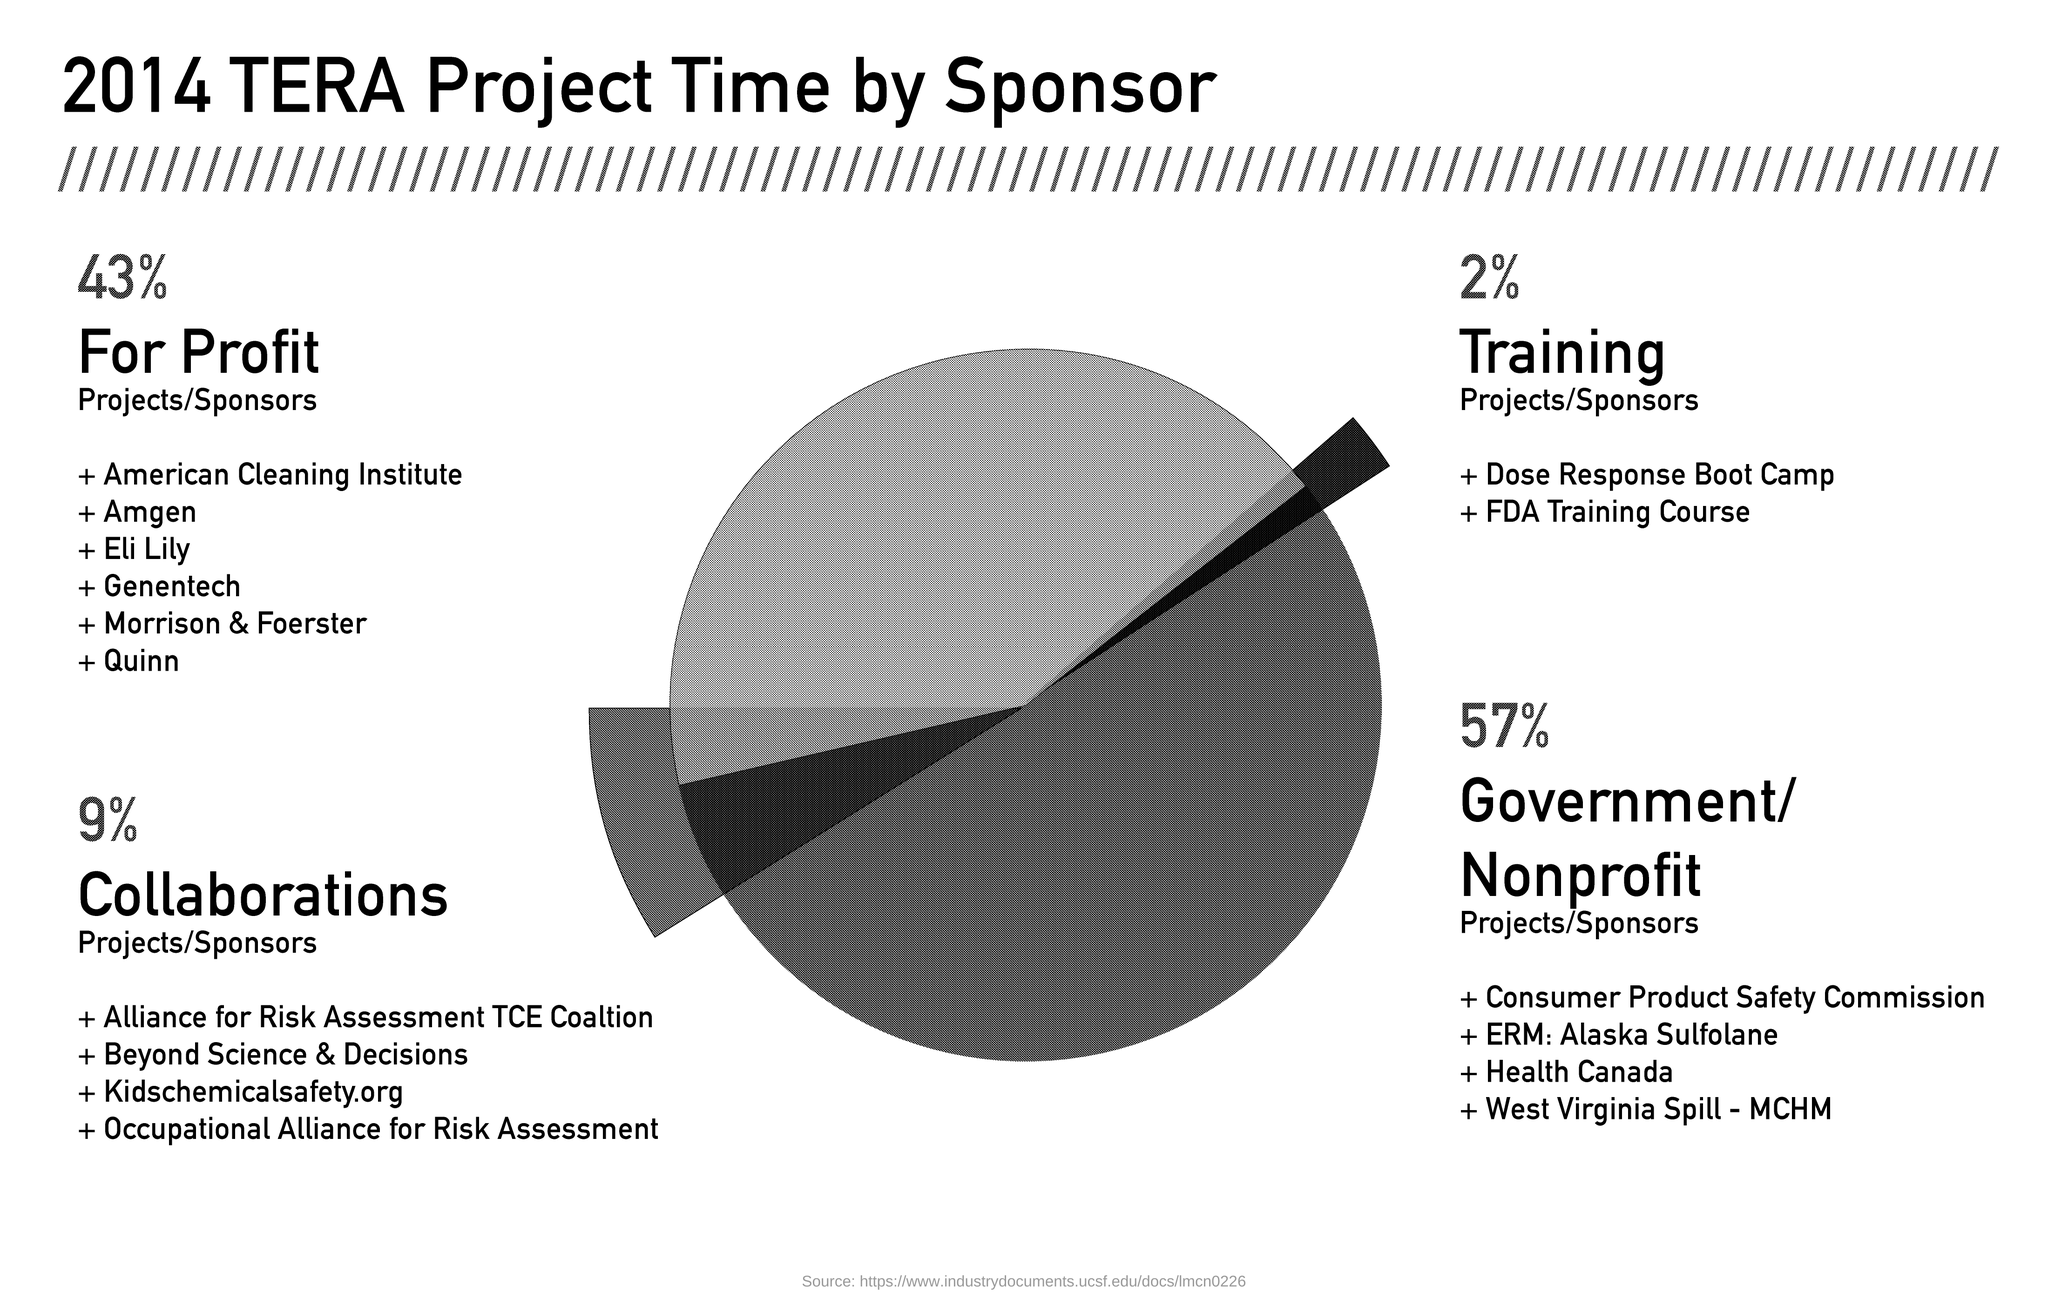What is the title of the document?
Offer a very short reply. 2014 TERA Project Time by Sponsor. 